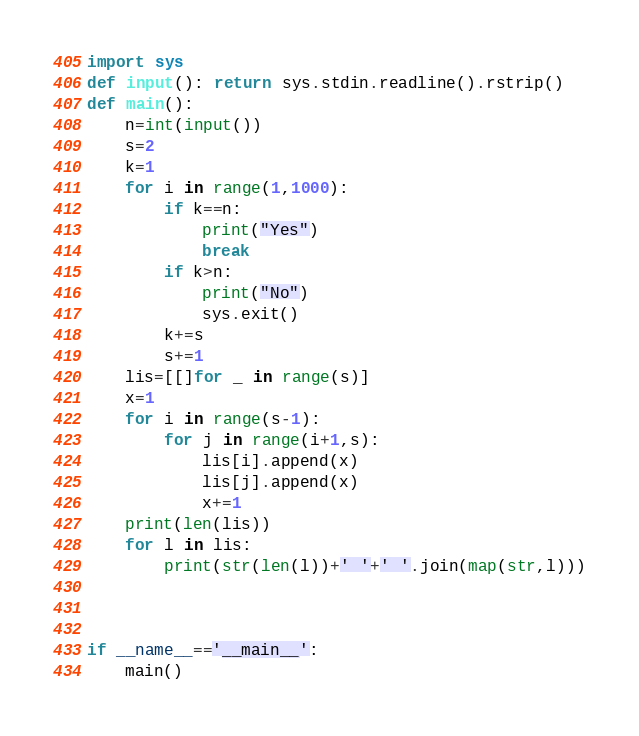<code> <loc_0><loc_0><loc_500><loc_500><_Python_>import sys
def input(): return sys.stdin.readline().rstrip()
def main():
    n=int(input())
    s=2
    k=1
    for i in range(1,1000):
        if k==n:
            print("Yes")
            break
        if k>n:
            print("No")
            sys.exit()
        k+=s
        s+=1
    lis=[[]for _ in range(s)]
    x=1
    for i in range(s-1):
        for j in range(i+1,s):
            lis[i].append(x)
            lis[j].append(x)
            x+=1
    print(len(lis))
    for l in lis:
        print(str(len(l))+' '+' '.join(map(str,l)))

    

if __name__=='__main__':
    main()</code> 